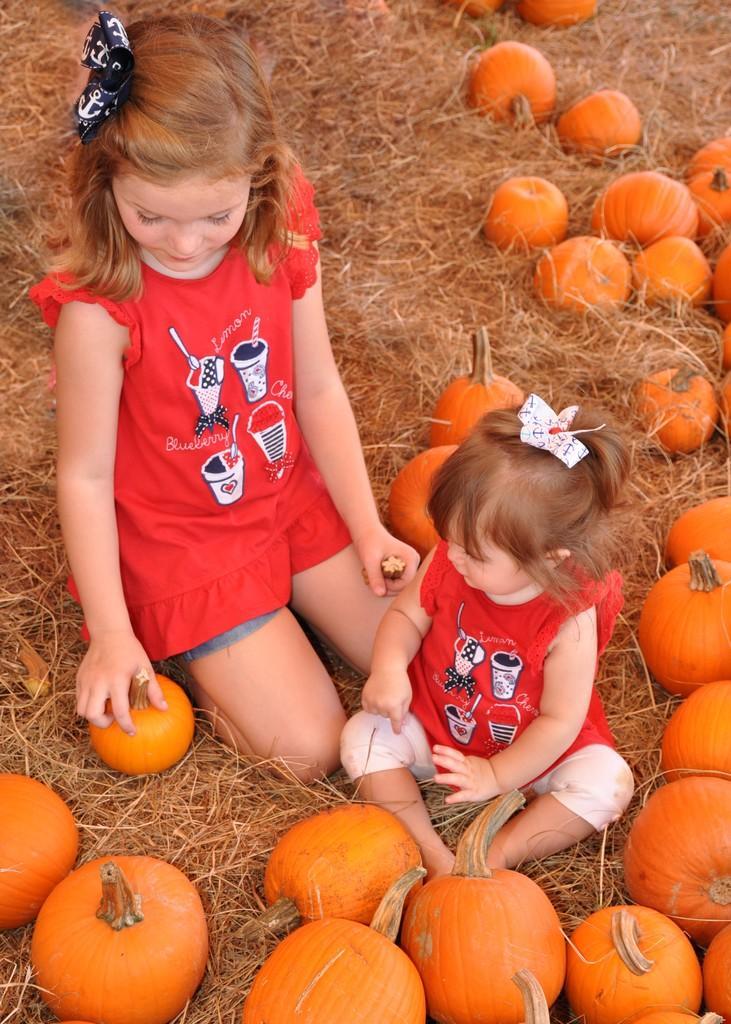Describe this image in one or two sentences. In this picture we see 2 little girls sitting on the dry grass and playing with the pumpkins. 